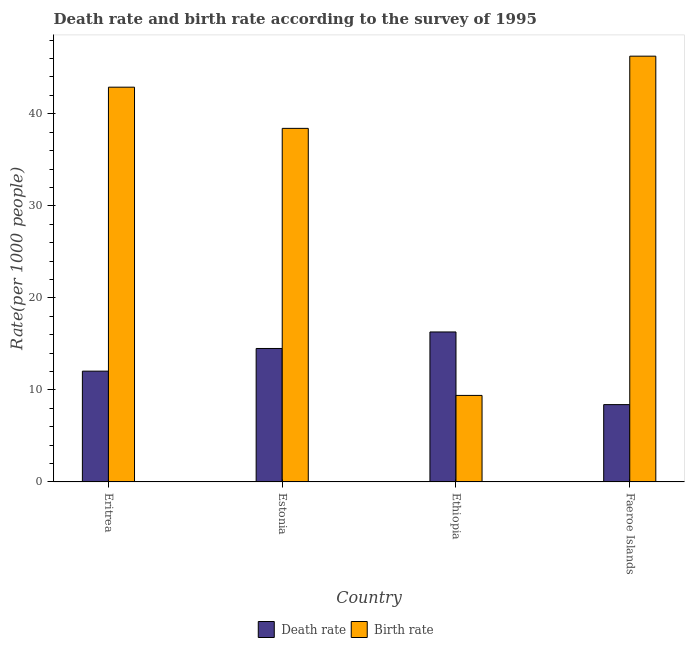How many groups of bars are there?
Provide a succinct answer. 4. Are the number of bars on each tick of the X-axis equal?
Offer a very short reply. Yes. What is the label of the 3rd group of bars from the left?
Provide a succinct answer. Ethiopia. What is the birth rate in Faeroe Islands?
Provide a short and direct response. 46.26. Across all countries, what is the maximum birth rate?
Offer a very short reply. 46.26. Across all countries, what is the minimum death rate?
Offer a terse response. 8.4. In which country was the death rate maximum?
Provide a succinct answer. Ethiopia. In which country was the birth rate minimum?
Offer a very short reply. Ethiopia. What is the total birth rate in the graph?
Offer a terse response. 136.97. What is the difference between the birth rate in Eritrea and that in Ethiopia?
Ensure brevity in your answer.  33.49. What is the difference between the birth rate in Estonia and the death rate in Ethiopia?
Provide a succinct answer. 22.12. What is the average death rate per country?
Your response must be concise. 12.81. What is the difference between the birth rate and death rate in Faeroe Islands?
Offer a terse response. 37.86. In how many countries, is the birth rate greater than 26 ?
Your response must be concise. 3. What is the ratio of the death rate in Eritrea to that in Faeroe Islands?
Your answer should be very brief. 1.43. What is the difference between the highest and the second highest birth rate?
Keep it short and to the point. 3.37. What is the difference between the highest and the lowest death rate?
Your answer should be very brief. 7.9. What does the 1st bar from the left in Ethiopia represents?
Keep it short and to the point. Death rate. What does the 1st bar from the right in Faeroe Islands represents?
Offer a very short reply. Birth rate. How many bars are there?
Give a very brief answer. 8. Are all the bars in the graph horizontal?
Ensure brevity in your answer.  No. How many countries are there in the graph?
Your answer should be compact. 4. What is the difference between two consecutive major ticks on the Y-axis?
Make the answer very short. 10. Are the values on the major ticks of Y-axis written in scientific E-notation?
Keep it short and to the point. No. Does the graph contain grids?
Keep it short and to the point. No. Where does the legend appear in the graph?
Offer a terse response. Bottom center. What is the title of the graph?
Ensure brevity in your answer.  Death rate and birth rate according to the survey of 1995. Does "Infant" appear as one of the legend labels in the graph?
Give a very brief answer. No. What is the label or title of the Y-axis?
Ensure brevity in your answer.  Rate(per 1000 people). What is the Rate(per 1000 people) of Death rate in Eritrea?
Give a very brief answer. 12.04. What is the Rate(per 1000 people) in Birth rate in Eritrea?
Give a very brief answer. 42.89. What is the Rate(per 1000 people) in Birth rate in Estonia?
Make the answer very short. 38.42. What is the Rate(per 1000 people) in Death rate in Ethiopia?
Your answer should be compact. 16.3. What is the Rate(per 1000 people) in Death rate in Faeroe Islands?
Your answer should be very brief. 8.4. What is the Rate(per 1000 people) in Birth rate in Faeroe Islands?
Ensure brevity in your answer.  46.26. Across all countries, what is the maximum Rate(per 1000 people) of Death rate?
Provide a short and direct response. 16.3. Across all countries, what is the maximum Rate(per 1000 people) of Birth rate?
Offer a very short reply. 46.26. Across all countries, what is the minimum Rate(per 1000 people) of Death rate?
Give a very brief answer. 8.4. Across all countries, what is the minimum Rate(per 1000 people) in Birth rate?
Offer a terse response. 9.4. What is the total Rate(per 1000 people) in Death rate in the graph?
Give a very brief answer. 51.23. What is the total Rate(per 1000 people) in Birth rate in the graph?
Offer a very short reply. 136.97. What is the difference between the Rate(per 1000 people) in Death rate in Eritrea and that in Estonia?
Your response must be concise. -2.46. What is the difference between the Rate(per 1000 people) of Birth rate in Eritrea and that in Estonia?
Your answer should be very brief. 4.47. What is the difference between the Rate(per 1000 people) of Death rate in Eritrea and that in Ethiopia?
Provide a succinct answer. -4.26. What is the difference between the Rate(per 1000 people) of Birth rate in Eritrea and that in Ethiopia?
Your answer should be compact. 33.49. What is the difference between the Rate(per 1000 people) in Death rate in Eritrea and that in Faeroe Islands?
Your answer should be very brief. 3.64. What is the difference between the Rate(per 1000 people) of Birth rate in Eritrea and that in Faeroe Islands?
Offer a very short reply. -3.37. What is the difference between the Rate(per 1000 people) in Death rate in Estonia and that in Ethiopia?
Your answer should be very brief. -1.79. What is the difference between the Rate(per 1000 people) in Birth rate in Estonia and that in Ethiopia?
Your response must be concise. 29.02. What is the difference between the Rate(per 1000 people) in Birth rate in Estonia and that in Faeroe Islands?
Your answer should be compact. -7.84. What is the difference between the Rate(per 1000 people) of Death rate in Ethiopia and that in Faeroe Islands?
Offer a very short reply. 7.89. What is the difference between the Rate(per 1000 people) of Birth rate in Ethiopia and that in Faeroe Islands?
Offer a terse response. -36.86. What is the difference between the Rate(per 1000 people) of Death rate in Eritrea and the Rate(per 1000 people) of Birth rate in Estonia?
Your answer should be compact. -26.38. What is the difference between the Rate(per 1000 people) of Death rate in Eritrea and the Rate(per 1000 people) of Birth rate in Ethiopia?
Offer a terse response. 2.64. What is the difference between the Rate(per 1000 people) in Death rate in Eritrea and the Rate(per 1000 people) in Birth rate in Faeroe Islands?
Provide a succinct answer. -34.23. What is the difference between the Rate(per 1000 people) in Death rate in Estonia and the Rate(per 1000 people) in Birth rate in Faeroe Islands?
Make the answer very short. -31.76. What is the difference between the Rate(per 1000 people) of Death rate in Ethiopia and the Rate(per 1000 people) of Birth rate in Faeroe Islands?
Keep it short and to the point. -29.97. What is the average Rate(per 1000 people) of Death rate per country?
Offer a terse response. 12.81. What is the average Rate(per 1000 people) of Birth rate per country?
Ensure brevity in your answer.  34.24. What is the difference between the Rate(per 1000 people) of Death rate and Rate(per 1000 people) of Birth rate in Eritrea?
Make the answer very short. -30.86. What is the difference between the Rate(per 1000 people) in Death rate and Rate(per 1000 people) in Birth rate in Estonia?
Offer a terse response. -23.92. What is the difference between the Rate(per 1000 people) of Death rate and Rate(per 1000 people) of Birth rate in Ethiopia?
Make the answer very short. 6.89. What is the difference between the Rate(per 1000 people) of Death rate and Rate(per 1000 people) of Birth rate in Faeroe Islands?
Provide a short and direct response. -37.86. What is the ratio of the Rate(per 1000 people) in Death rate in Eritrea to that in Estonia?
Offer a terse response. 0.83. What is the ratio of the Rate(per 1000 people) in Birth rate in Eritrea to that in Estonia?
Provide a succinct answer. 1.12. What is the ratio of the Rate(per 1000 people) in Death rate in Eritrea to that in Ethiopia?
Your response must be concise. 0.74. What is the ratio of the Rate(per 1000 people) of Birth rate in Eritrea to that in Ethiopia?
Your answer should be very brief. 4.56. What is the ratio of the Rate(per 1000 people) in Death rate in Eritrea to that in Faeroe Islands?
Give a very brief answer. 1.43. What is the ratio of the Rate(per 1000 people) in Birth rate in Eritrea to that in Faeroe Islands?
Your answer should be very brief. 0.93. What is the ratio of the Rate(per 1000 people) of Death rate in Estonia to that in Ethiopia?
Provide a succinct answer. 0.89. What is the ratio of the Rate(per 1000 people) of Birth rate in Estonia to that in Ethiopia?
Your response must be concise. 4.09. What is the ratio of the Rate(per 1000 people) in Death rate in Estonia to that in Faeroe Islands?
Make the answer very short. 1.73. What is the ratio of the Rate(per 1000 people) of Birth rate in Estonia to that in Faeroe Islands?
Ensure brevity in your answer.  0.83. What is the ratio of the Rate(per 1000 people) in Death rate in Ethiopia to that in Faeroe Islands?
Offer a terse response. 1.94. What is the ratio of the Rate(per 1000 people) of Birth rate in Ethiopia to that in Faeroe Islands?
Ensure brevity in your answer.  0.2. What is the difference between the highest and the second highest Rate(per 1000 people) in Death rate?
Provide a succinct answer. 1.79. What is the difference between the highest and the second highest Rate(per 1000 people) of Birth rate?
Your response must be concise. 3.37. What is the difference between the highest and the lowest Rate(per 1000 people) of Death rate?
Offer a terse response. 7.89. What is the difference between the highest and the lowest Rate(per 1000 people) in Birth rate?
Ensure brevity in your answer.  36.86. 